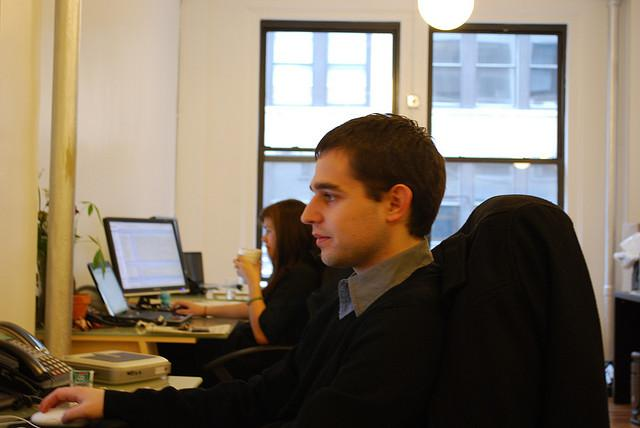What is he doing? working 